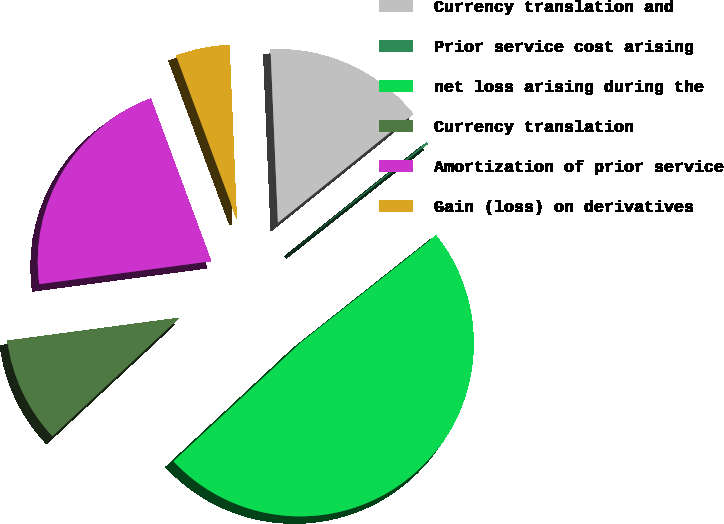Convert chart to OTSL. <chart><loc_0><loc_0><loc_500><loc_500><pie_chart><fcel>Currency translation and<fcel>Prior service cost arising<fcel>net loss arising during the<fcel>Currency translation<fcel>Amortization of prior service<fcel>Gain (loss) on derivatives<nl><fcel>14.89%<fcel>0.13%<fcel>48.71%<fcel>9.84%<fcel>21.45%<fcel>4.98%<nl></chart> 